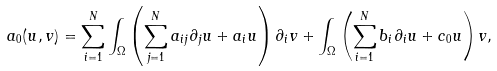<formula> <loc_0><loc_0><loc_500><loc_500>a _ { 0 } ( u , v ) = \sum _ { i = 1 } ^ { N } \int _ { \Omega } \left ( \sum _ { j = 1 } ^ { N } a _ { i j } \partial _ { j } u + a _ { i } u \right ) \partial _ { i } v + \int _ { \Omega } \left ( \sum _ { i = 1 } ^ { N } b _ { i } \partial _ { i } u + c _ { 0 } u \right ) v ,</formula> 